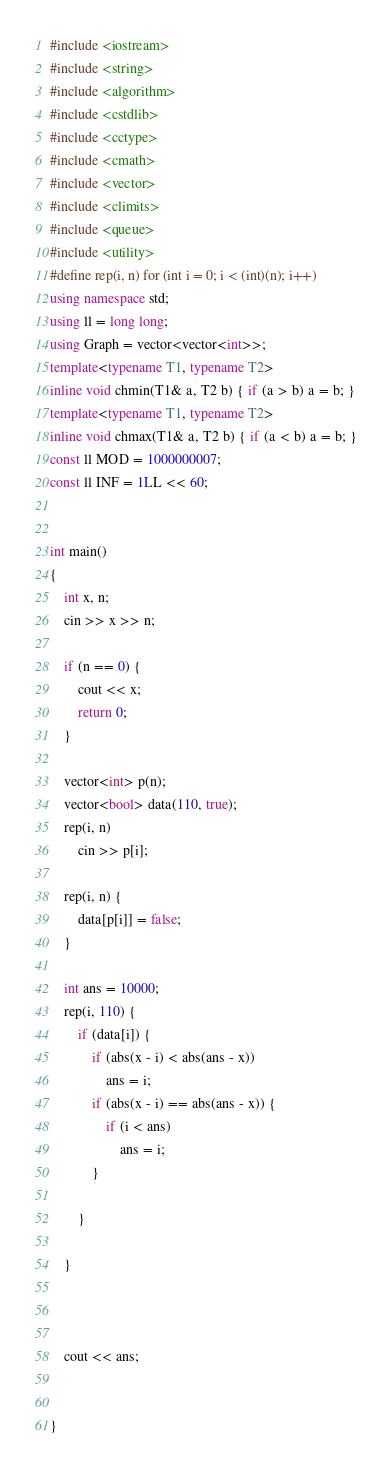<code> <loc_0><loc_0><loc_500><loc_500><_C++_>#include <iostream>
#include <string>
#include <algorithm>
#include <cstdlib>
#include <cctype>
#include <cmath>
#include <vector>
#include <climits>
#include <queue>
#include <utility>
#define rep(i, n) for (int i = 0; i < (int)(n); i++)
using namespace std;
using ll = long long;
using Graph = vector<vector<int>>;
template<typename T1, typename T2>
inline void chmin(T1& a, T2 b) { if (a > b) a = b; }
template<typename T1, typename T2>
inline void chmax(T1& a, T2 b) { if (a < b) a = b; }
const ll MOD = 1000000007;
const ll INF = 1LL << 60;


int main()
{
	int x, n;
	cin >> x >> n;

	if (n == 0) {
		cout << x;
		return 0;
	}

	vector<int> p(n);
	vector<bool> data(110, true);
	rep(i, n)
		cin >> p[i];

	rep(i, n) {
		data[p[i]] = false;
	}
	
	int ans = 10000;
	rep(i, 110) {
		if (data[i]) {
			if (abs(x - i) < abs(ans - x))
				ans = i;
			if (abs(x - i) == abs(ans - x)) {
				if (i < ans)
					ans = i;
			}
				
		}

	}



	cout << ans;
	

}


</code> 